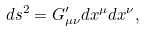Convert formula to latex. <formula><loc_0><loc_0><loc_500><loc_500>d s ^ { 2 } = G _ { \mu \nu } ^ { \prime } d x ^ { \mu } d x ^ { \nu } ,</formula> 